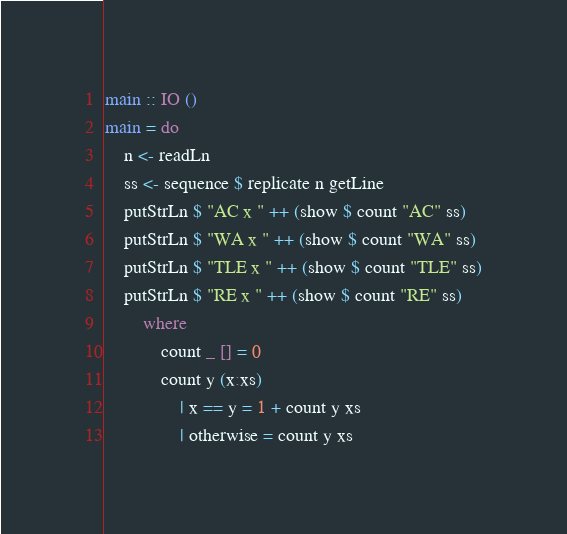Convert code to text. <code><loc_0><loc_0><loc_500><loc_500><_Haskell_>main :: IO ()
main = do
    n <- readLn
    ss <- sequence $ replicate n getLine
    putStrLn $ "AC x " ++ (show $ count "AC" ss)
    putStrLn $ "WA x " ++ (show $ count "WA" ss)
    putStrLn $ "TLE x " ++ (show $ count "TLE" ss)
    putStrLn $ "RE x " ++ (show $ count "RE" ss)
        where 
            count _ [] = 0
            count y (x:xs) 
                | x == y = 1 + count y xs
                | otherwise = count y xs</code> 